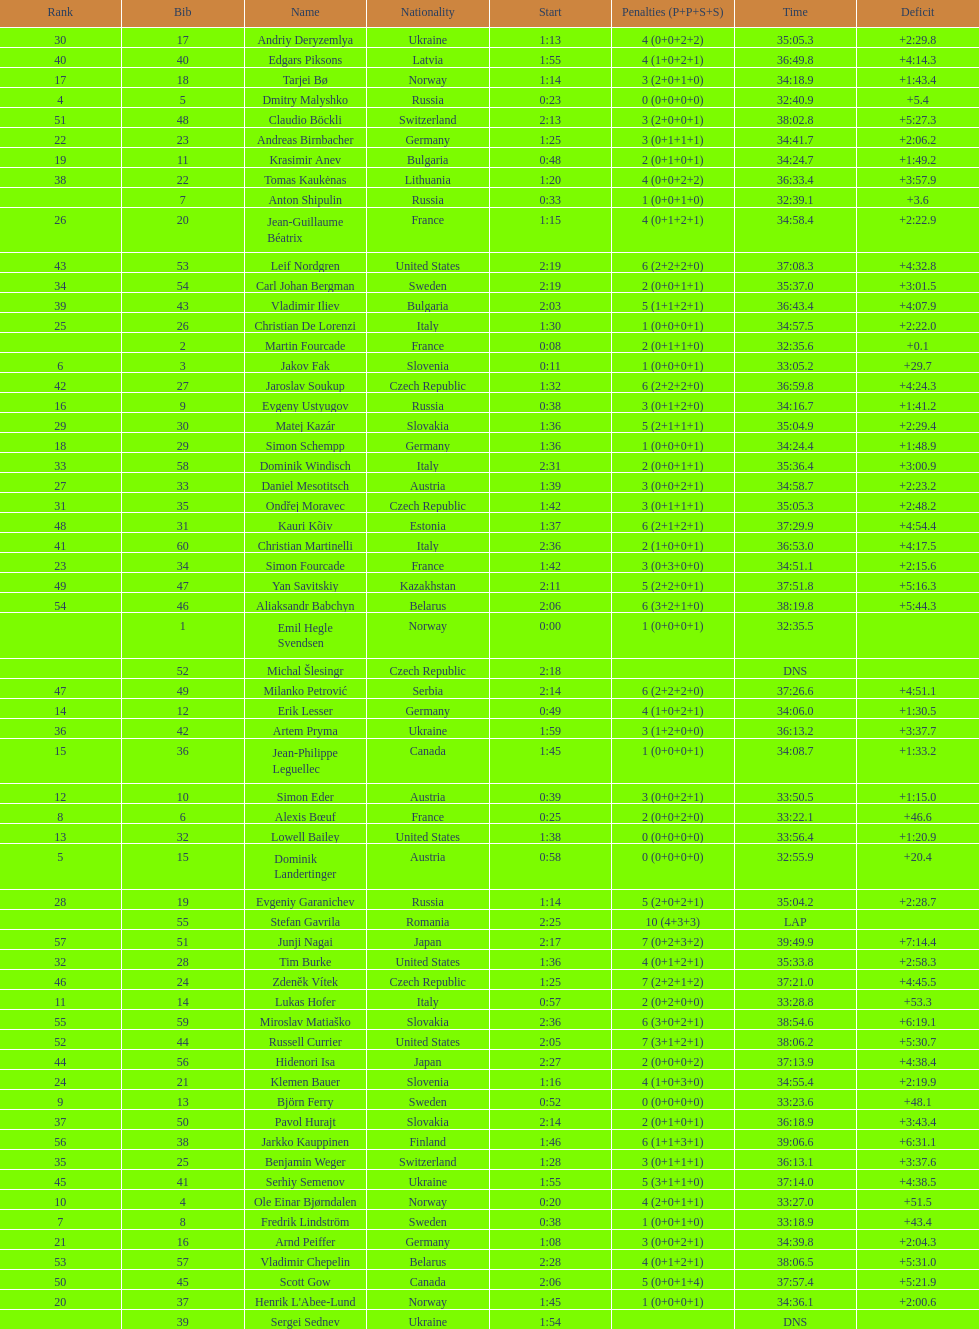What is the largest penalty? 10. Write the full table. {'header': ['Rank', 'Bib', 'Name', 'Nationality', 'Start', 'Penalties (P+P+S+S)', 'Time', 'Deficit'], 'rows': [['30', '17', 'Andriy Deryzemlya', 'Ukraine', '1:13', '4 (0+0+2+2)', '35:05.3', '+2:29.8'], ['40', '40', 'Edgars Piksons', 'Latvia', '1:55', '4 (1+0+2+1)', '36:49.8', '+4:14.3'], ['17', '18', 'Tarjei Bø', 'Norway', '1:14', '3 (2+0+1+0)', '34:18.9', '+1:43.4'], ['4', '5', 'Dmitry Malyshko', 'Russia', '0:23', '0 (0+0+0+0)', '32:40.9', '+5.4'], ['51', '48', 'Claudio Böckli', 'Switzerland', '2:13', '3 (2+0+0+1)', '38:02.8', '+5:27.3'], ['22', '23', 'Andreas Birnbacher', 'Germany', '1:25', '3 (0+1+1+1)', '34:41.7', '+2:06.2'], ['19', '11', 'Krasimir Anev', 'Bulgaria', '0:48', '2 (0+1+0+1)', '34:24.7', '+1:49.2'], ['38', '22', 'Tomas Kaukėnas', 'Lithuania', '1:20', '4 (0+0+2+2)', '36:33.4', '+3:57.9'], ['', '7', 'Anton Shipulin', 'Russia', '0:33', '1 (0+0+1+0)', '32:39.1', '+3.6'], ['26', '20', 'Jean-Guillaume Béatrix', 'France', '1:15', '4 (0+1+2+1)', '34:58.4', '+2:22.9'], ['43', '53', 'Leif Nordgren', 'United States', '2:19', '6 (2+2+2+0)', '37:08.3', '+4:32.8'], ['34', '54', 'Carl Johan Bergman', 'Sweden', '2:19', '2 (0+0+1+1)', '35:37.0', '+3:01.5'], ['39', '43', 'Vladimir Iliev', 'Bulgaria', '2:03', '5 (1+1+2+1)', '36:43.4', '+4:07.9'], ['25', '26', 'Christian De Lorenzi', 'Italy', '1:30', '1 (0+0+0+1)', '34:57.5', '+2:22.0'], ['', '2', 'Martin Fourcade', 'France', '0:08', '2 (0+1+1+0)', '32:35.6', '+0.1'], ['6', '3', 'Jakov Fak', 'Slovenia', '0:11', '1 (0+0+0+1)', '33:05.2', '+29.7'], ['42', '27', 'Jaroslav Soukup', 'Czech Republic', '1:32', '6 (2+2+2+0)', '36:59.8', '+4:24.3'], ['16', '9', 'Evgeny Ustyugov', 'Russia', '0:38', '3 (0+1+2+0)', '34:16.7', '+1:41.2'], ['29', '30', 'Matej Kazár', 'Slovakia', '1:36', '5 (2+1+1+1)', '35:04.9', '+2:29.4'], ['18', '29', 'Simon Schempp', 'Germany', '1:36', '1 (0+0+0+1)', '34:24.4', '+1:48.9'], ['33', '58', 'Dominik Windisch', 'Italy', '2:31', '2 (0+0+1+1)', '35:36.4', '+3:00.9'], ['27', '33', 'Daniel Mesotitsch', 'Austria', '1:39', '3 (0+0+2+1)', '34:58.7', '+2:23.2'], ['31', '35', 'Ondřej Moravec', 'Czech Republic', '1:42', '3 (0+1+1+1)', '35:05.3', '+2:48.2'], ['48', '31', 'Kauri Kõiv', 'Estonia', '1:37', '6 (2+1+2+1)', '37:29.9', '+4:54.4'], ['41', '60', 'Christian Martinelli', 'Italy', '2:36', '2 (1+0+0+1)', '36:53.0', '+4:17.5'], ['23', '34', 'Simon Fourcade', 'France', '1:42', '3 (0+3+0+0)', '34:51.1', '+2:15.6'], ['49', '47', 'Yan Savitskiy', 'Kazakhstan', '2:11', '5 (2+2+0+1)', '37:51.8', '+5:16.3'], ['54', '46', 'Aliaksandr Babchyn', 'Belarus', '2:06', '6 (3+2+1+0)', '38:19.8', '+5:44.3'], ['', '1', 'Emil Hegle Svendsen', 'Norway', '0:00', '1 (0+0+0+1)', '32:35.5', ''], ['', '52', 'Michal Šlesingr', 'Czech Republic', '2:18', '', 'DNS', ''], ['47', '49', 'Milanko Petrović', 'Serbia', '2:14', '6 (2+2+2+0)', '37:26.6', '+4:51.1'], ['14', '12', 'Erik Lesser', 'Germany', '0:49', '4 (1+0+2+1)', '34:06.0', '+1:30.5'], ['36', '42', 'Artem Pryma', 'Ukraine', '1:59', '3 (1+2+0+0)', '36:13.2', '+3:37.7'], ['15', '36', 'Jean-Philippe Leguellec', 'Canada', '1:45', '1 (0+0+0+1)', '34:08.7', '+1:33.2'], ['12', '10', 'Simon Eder', 'Austria', '0:39', '3 (0+0+2+1)', '33:50.5', '+1:15.0'], ['8', '6', 'Alexis Bœuf', 'France', '0:25', '2 (0+0+2+0)', '33:22.1', '+46.6'], ['13', '32', 'Lowell Bailey', 'United States', '1:38', '0 (0+0+0+0)', '33:56.4', '+1:20.9'], ['5', '15', 'Dominik Landertinger', 'Austria', '0:58', '0 (0+0+0+0)', '32:55.9', '+20.4'], ['28', '19', 'Evgeniy Garanichev', 'Russia', '1:14', '5 (2+0+2+1)', '35:04.2', '+2:28.7'], ['', '55', 'Stefan Gavrila', 'Romania', '2:25', '10 (4+3+3)', 'LAP', ''], ['57', '51', 'Junji Nagai', 'Japan', '2:17', '7 (0+2+3+2)', '39:49.9', '+7:14.4'], ['32', '28', 'Tim Burke', 'United States', '1:36', '4 (0+1+2+1)', '35:33.8', '+2:58.3'], ['46', '24', 'Zdeněk Vítek', 'Czech Republic', '1:25', '7 (2+2+1+2)', '37:21.0', '+4:45.5'], ['11', '14', 'Lukas Hofer', 'Italy', '0:57', '2 (0+2+0+0)', '33:28.8', '+53.3'], ['55', '59', 'Miroslav Matiaško', 'Slovakia', '2:36', '6 (3+0+2+1)', '38:54.6', '+6:19.1'], ['52', '44', 'Russell Currier', 'United States', '2:05', '7 (3+1+2+1)', '38:06.2', '+5:30.7'], ['44', '56', 'Hidenori Isa', 'Japan', '2:27', '2 (0+0+0+2)', '37:13.9', '+4:38.4'], ['24', '21', 'Klemen Bauer', 'Slovenia', '1:16', '4 (1+0+3+0)', '34:55.4', '+2:19.9'], ['9', '13', 'Björn Ferry', 'Sweden', '0:52', '0 (0+0+0+0)', '33:23.6', '+48.1'], ['37', '50', 'Pavol Hurajt', 'Slovakia', '2:14', '2 (0+1+0+1)', '36:18.9', '+3:43.4'], ['56', '38', 'Jarkko Kauppinen', 'Finland', '1:46', '6 (1+1+3+1)', '39:06.6', '+6:31.1'], ['35', '25', 'Benjamin Weger', 'Switzerland', '1:28', '3 (0+1+1+1)', '36:13.1', '+3:37.6'], ['45', '41', 'Serhiy Semenov', 'Ukraine', '1:55', '5 (3+1+1+0)', '37:14.0', '+4:38.5'], ['10', '4', 'Ole Einar Bjørndalen', 'Norway', '0:20', '4 (2+0+1+1)', '33:27.0', '+51.5'], ['7', '8', 'Fredrik Lindström', 'Sweden', '0:38', '1 (0+0+1+0)', '33:18.9', '+43.4'], ['21', '16', 'Arnd Peiffer', 'Germany', '1:08', '3 (0+0+2+1)', '34:39.8', '+2:04.3'], ['53', '57', 'Vladimir Chepelin', 'Belarus', '2:28', '4 (0+1+2+1)', '38:06.5', '+5:31.0'], ['50', '45', 'Scott Gow', 'Canada', '2:06', '5 (0+0+1+4)', '37:57.4', '+5:21.9'], ['20', '37', "Henrik L'Abee-Lund", 'Norway', '1:45', '1 (0+0+0+1)', '34:36.1', '+2:00.6'], ['', '39', 'Sergei Sednev', 'Ukraine', '1:54', '', 'DNS', '']]} 